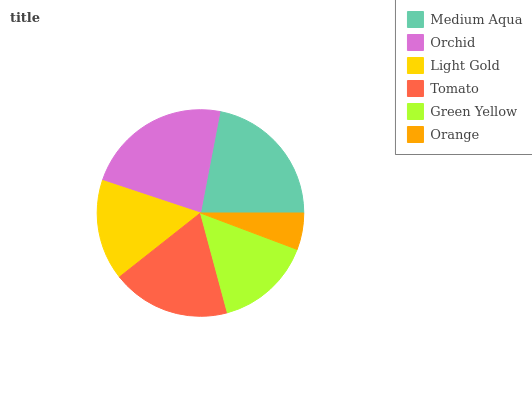Is Orange the minimum?
Answer yes or no. Yes. Is Orchid the maximum?
Answer yes or no. Yes. Is Light Gold the minimum?
Answer yes or no. No. Is Light Gold the maximum?
Answer yes or no. No. Is Orchid greater than Light Gold?
Answer yes or no. Yes. Is Light Gold less than Orchid?
Answer yes or no. Yes. Is Light Gold greater than Orchid?
Answer yes or no. No. Is Orchid less than Light Gold?
Answer yes or no. No. Is Tomato the high median?
Answer yes or no. Yes. Is Light Gold the low median?
Answer yes or no. Yes. Is Light Gold the high median?
Answer yes or no. No. Is Medium Aqua the low median?
Answer yes or no. No. 